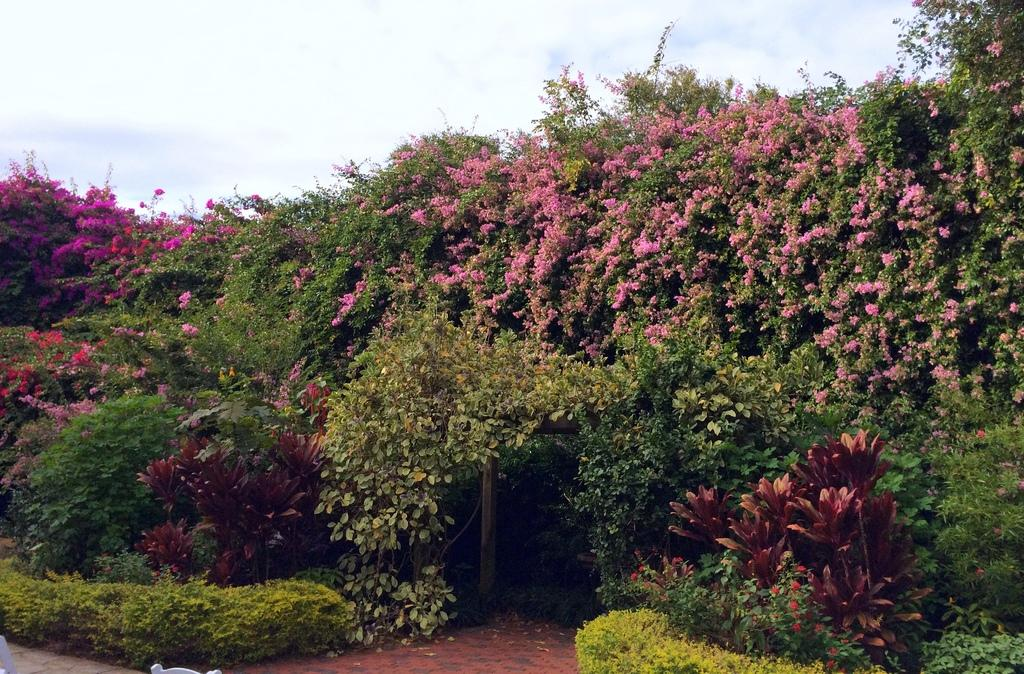What type of living organisms can be seen in the image? Plants and flowers are visible in the image. What is the main feature of the image? There is an entrance in the image. What can be seen in the sky in the image? The sky is visible in the image, and clouds are present. How many grapes are hanging from the plants in the image? There are no grapes present in the image; it features plants and flowers. What type of cakes are being served at the entrance in the image? There is no indication of cakes or any food being served in the image. 